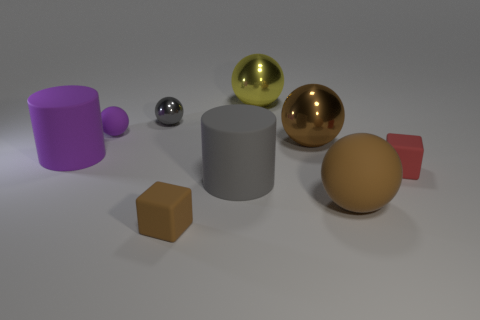What time of day does the lighting in the image suggest? The image suggests indoor lighting rather than natural light, making it difficult to determine the time of day based solely on the lighting conditions presented. 